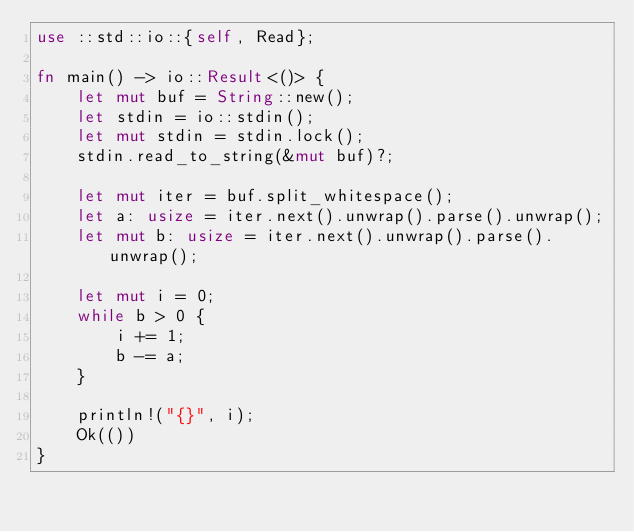<code> <loc_0><loc_0><loc_500><loc_500><_Rust_>use ::std::io::{self, Read};

fn main() -> io::Result<()> {
    let mut buf = String::new();
    let stdin = io::stdin();
    let mut stdin = stdin.lock();
    stdin.read_to_string(&mut buf)?;

    let mut iter = buf.split_whitespace();
    let a: usize = iter.next().unwrap().parse().unwrap();
    let mut b: usize = iter.next().unwrap().parse().unwrap();

    let mut i = 0;
    while b > 0 {
        i += 1;
        b -= a;
    }

    println!("{}", i);
    Ok(())
}
</code> 